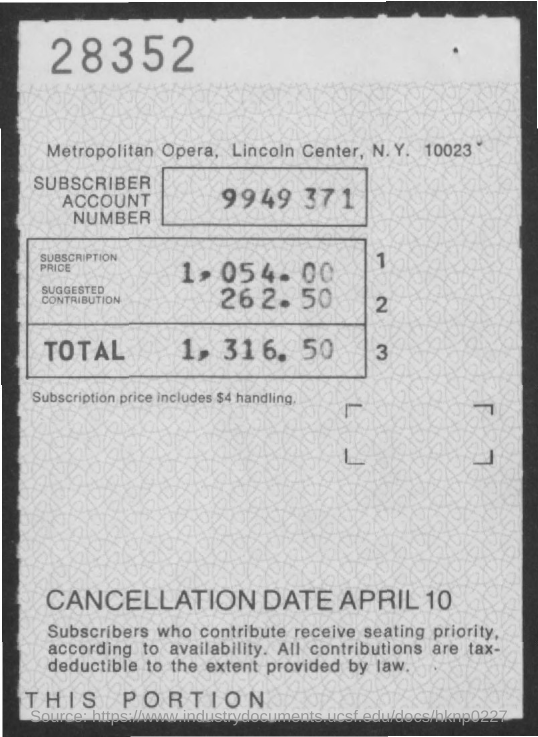Indicate a few pertinent items in this graphic. The total is 1,316.50. The subscription price is 1,054.00. The suggested contribution is 262.50. What is the Subscriber Account Number? It is 9949 371... 